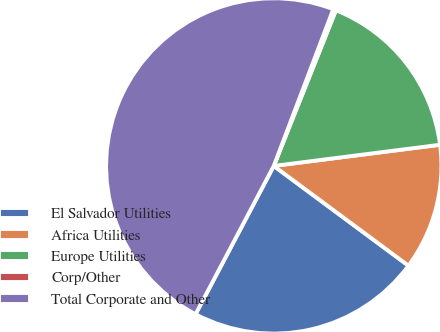Convert chart. <chart><loc_0><loc_0><loc_500><loc_500><pie_chart><fcel>El Salvador Utilities<fcel>Africa Utilities<fcel>Europe Utilities<fcel>Corp/Other<fcel>Total Corporate and Other<nl><fcel>22.58%<fcel>12.16%<fcel>16.94%<fcel>0.27%<fcel>48.05%<nl></chart> 